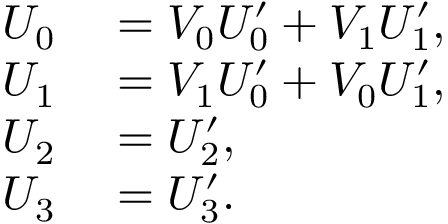<formula> <loc_0><loc_0><loc_500><loc_500>\begin{array} { r l } { U _ { 0 } } & = V _ { 0 } U _ { 0 } ^ { \prime } + V _ { 1 } U _ { 1 } ^ { \prime } , } \\ { U _ { 1 } } & = V _ { 1 } U _ { 0 } ^ { \prime } + V _ { 0 } U _ { 1 } ^ { \prime } , } \\ { U _ { 2 } } & = U _ { 2 } ^ { \prime } , } \\ { U _ { 3 } } & = U _ { 3 } ^ { \prime } . } \end{array}</formula> 